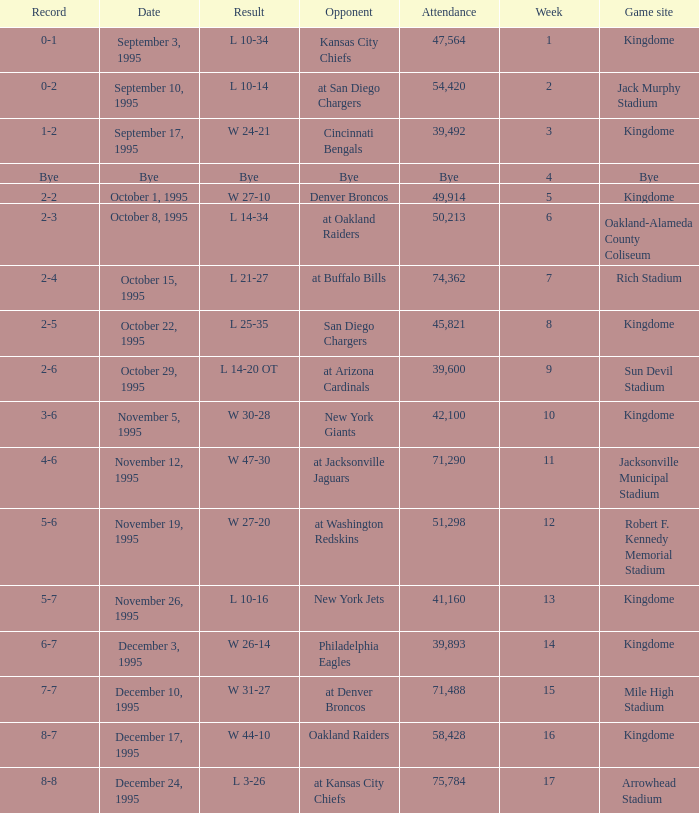Who was the opponent when the Seattle Seahawks had a record of 0-1? Kansas City Chiefs. 